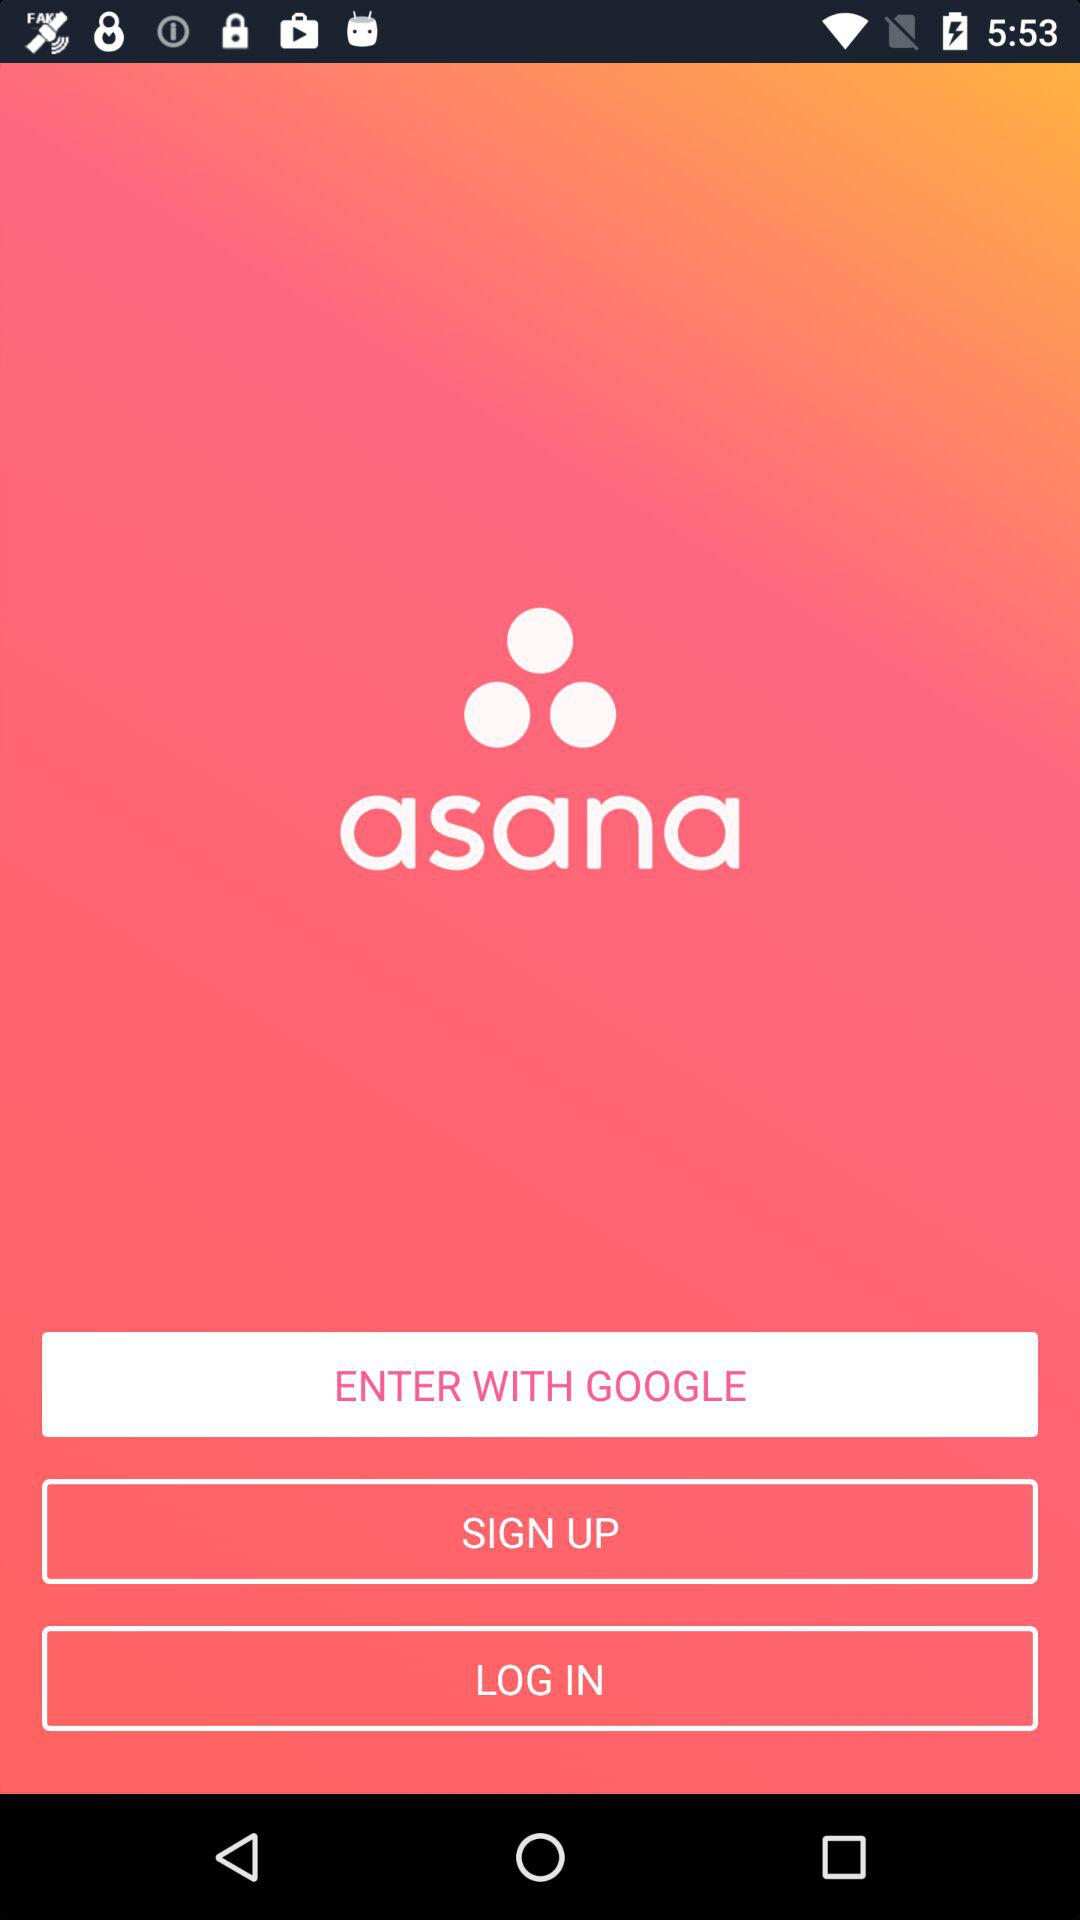What is the app name? The app name is "asana". 